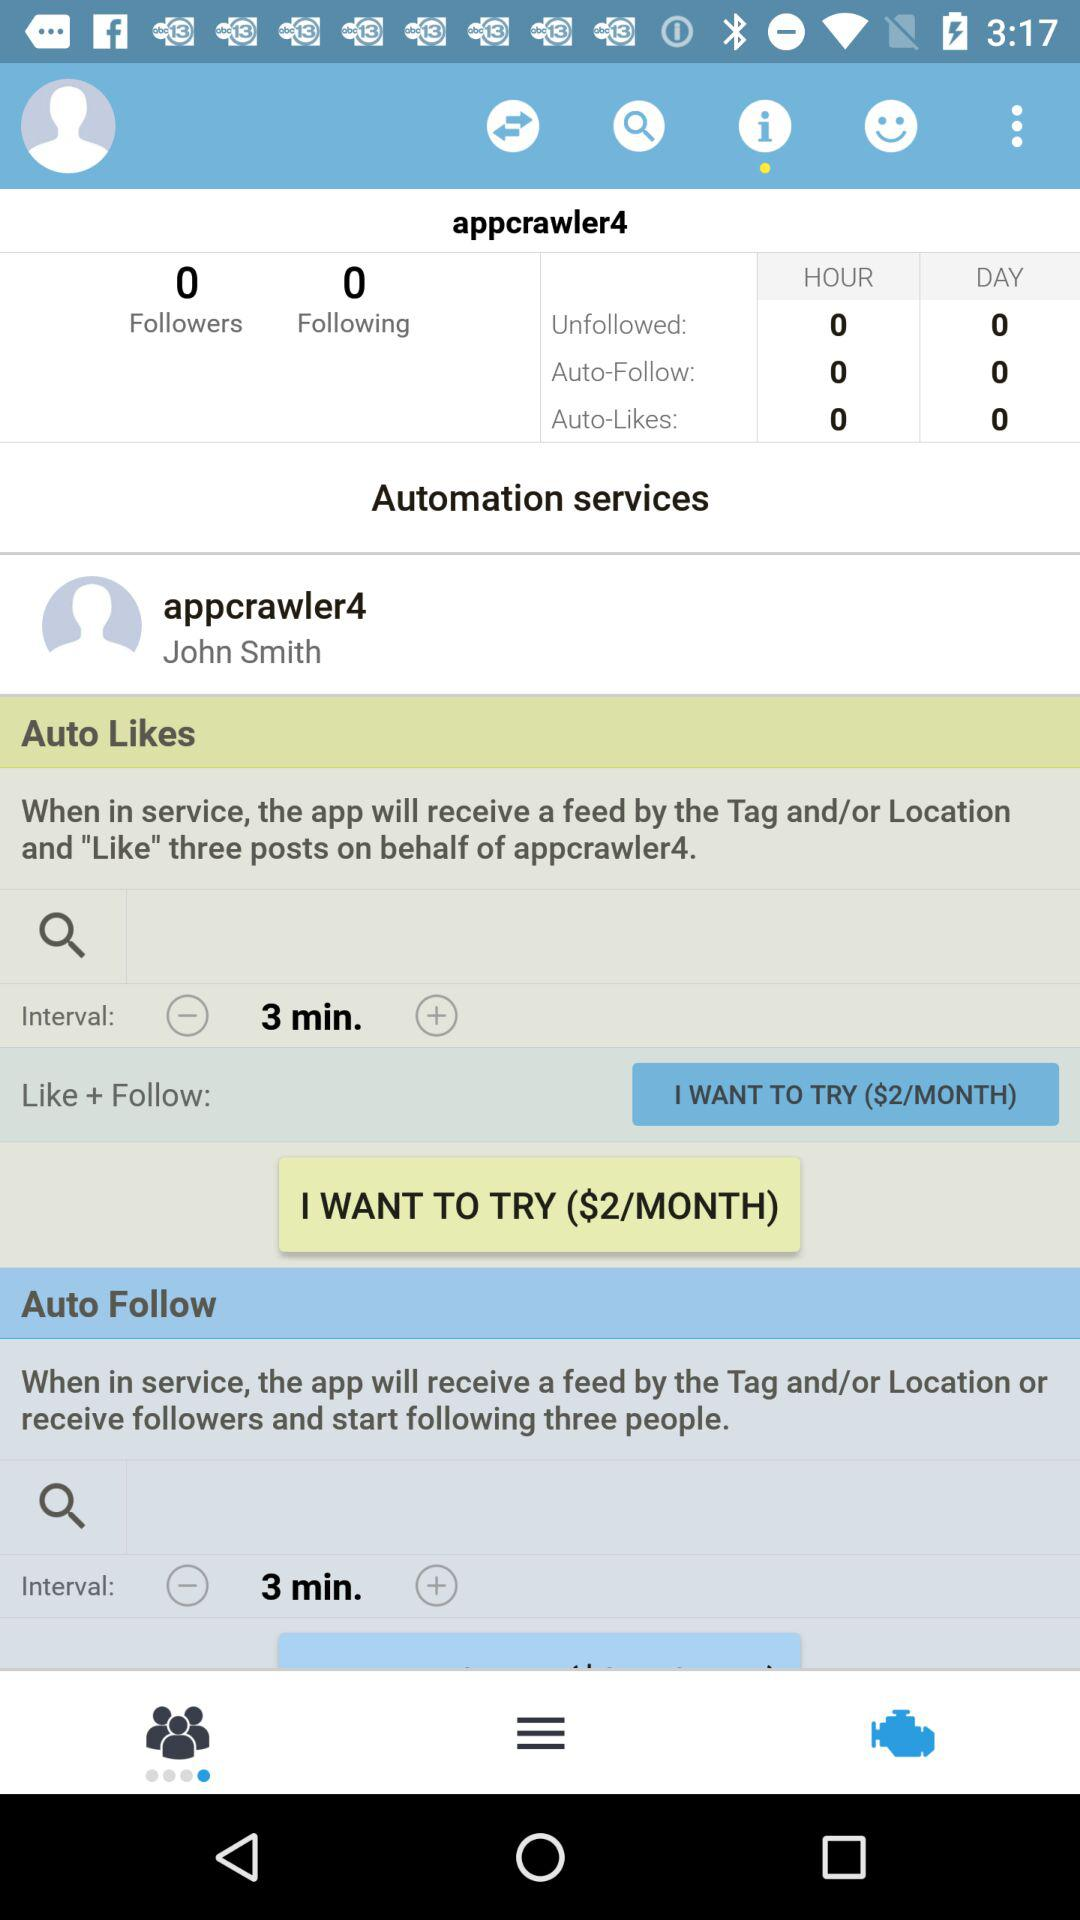What is the price of the "Auto-Likes" service? The price of the "Auto-Likes" service is $2/month. 